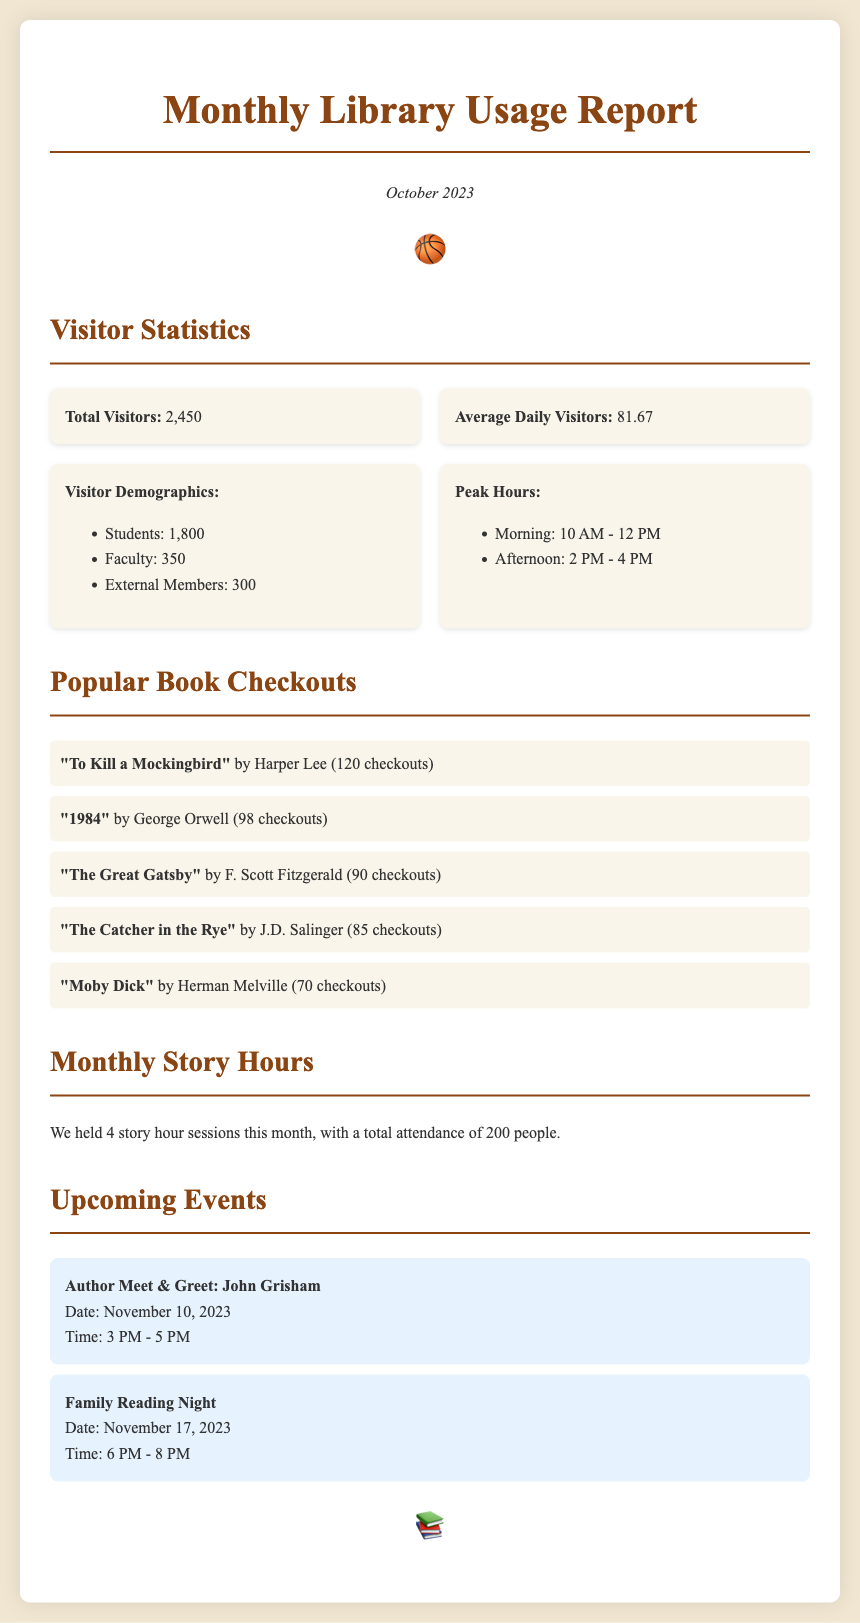What was the total number of visitors in October 2023? The total number of visitors is explicitly mentioned in the report, which is 2,450.
Answer: 2,450 What is the average number of daily visitors? The report provides the average daily visitors, which is calculated as 2,450 total visitors divided by the number of days in the month.
Answer: 81.67 How many story hour sessions were held this month? The report states that there were 4 story hour sessions conducted during the month.
Answer: 4 Who is the author for the upcoming meet & greet event? The document lists John Grisham as the author for the upcoming event.
Answer: John Grisham Which book had the highest number of checkouts? The document lists "To Kill a Mockingbird" by Harper Lee as the most checked-out book, with 120 checkouts.
Answer: "To Kill a Mockingbird" What was the total attendance for the story hours? The report indicates that the total attendance for story hours this month was 200 people.
Answer: 200 What time does the Family Reading Night event start? The document specifies that the Family Reading Night starts at 6 PM.
Answer: 6 PM What is the peak morning visiting hour? The report clearly states that the peak morning visiting hour is from 10 AM to 12 PM.
Answer: 10 AM - 12 PM How many external members visited the library? The document provides a breakdown of the visitor demographics, stating there were 300 external members.
Answer: 300 